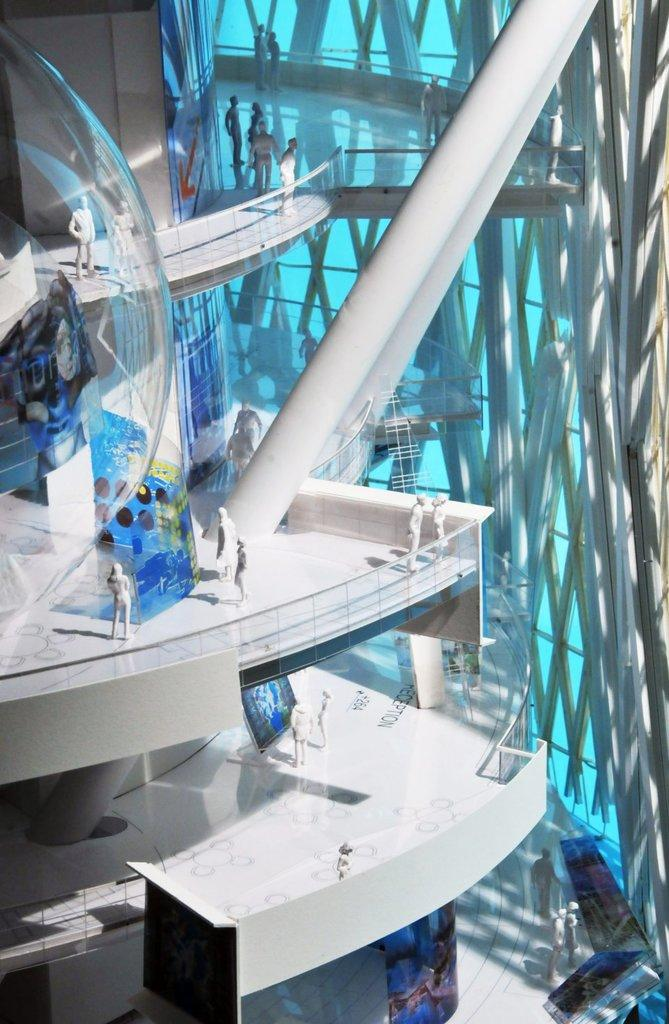What is the main subject of the image? The main subject of the image is a construction model. How many floors does the construction model have? The construction model has three floors. What can be seen on the floors of the model? There are people sculptures on the floors of the model. What else is present in the image besides the construction model? There are poles beside the construction model. What type of crime is being committed in the image? There is no indication of any crime being committed in the image; it features a construction model with people sculptures and poles. How many members are on the team that built the construction model? The provided facts do not mention any team or the number of members involved in building the construction model. 